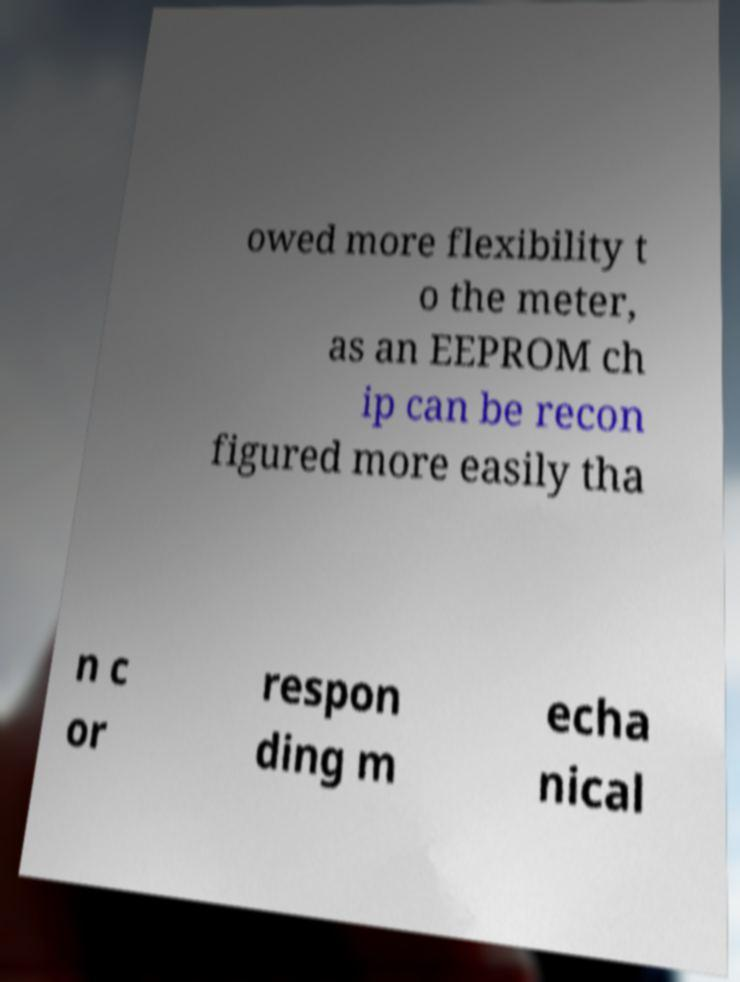Please read and relay the text visible in this image. What does it say? owed more flexibility t o the meter, as an EEPROM ch ip can be recon figured more easily tha n c or respon ding m echa nical 